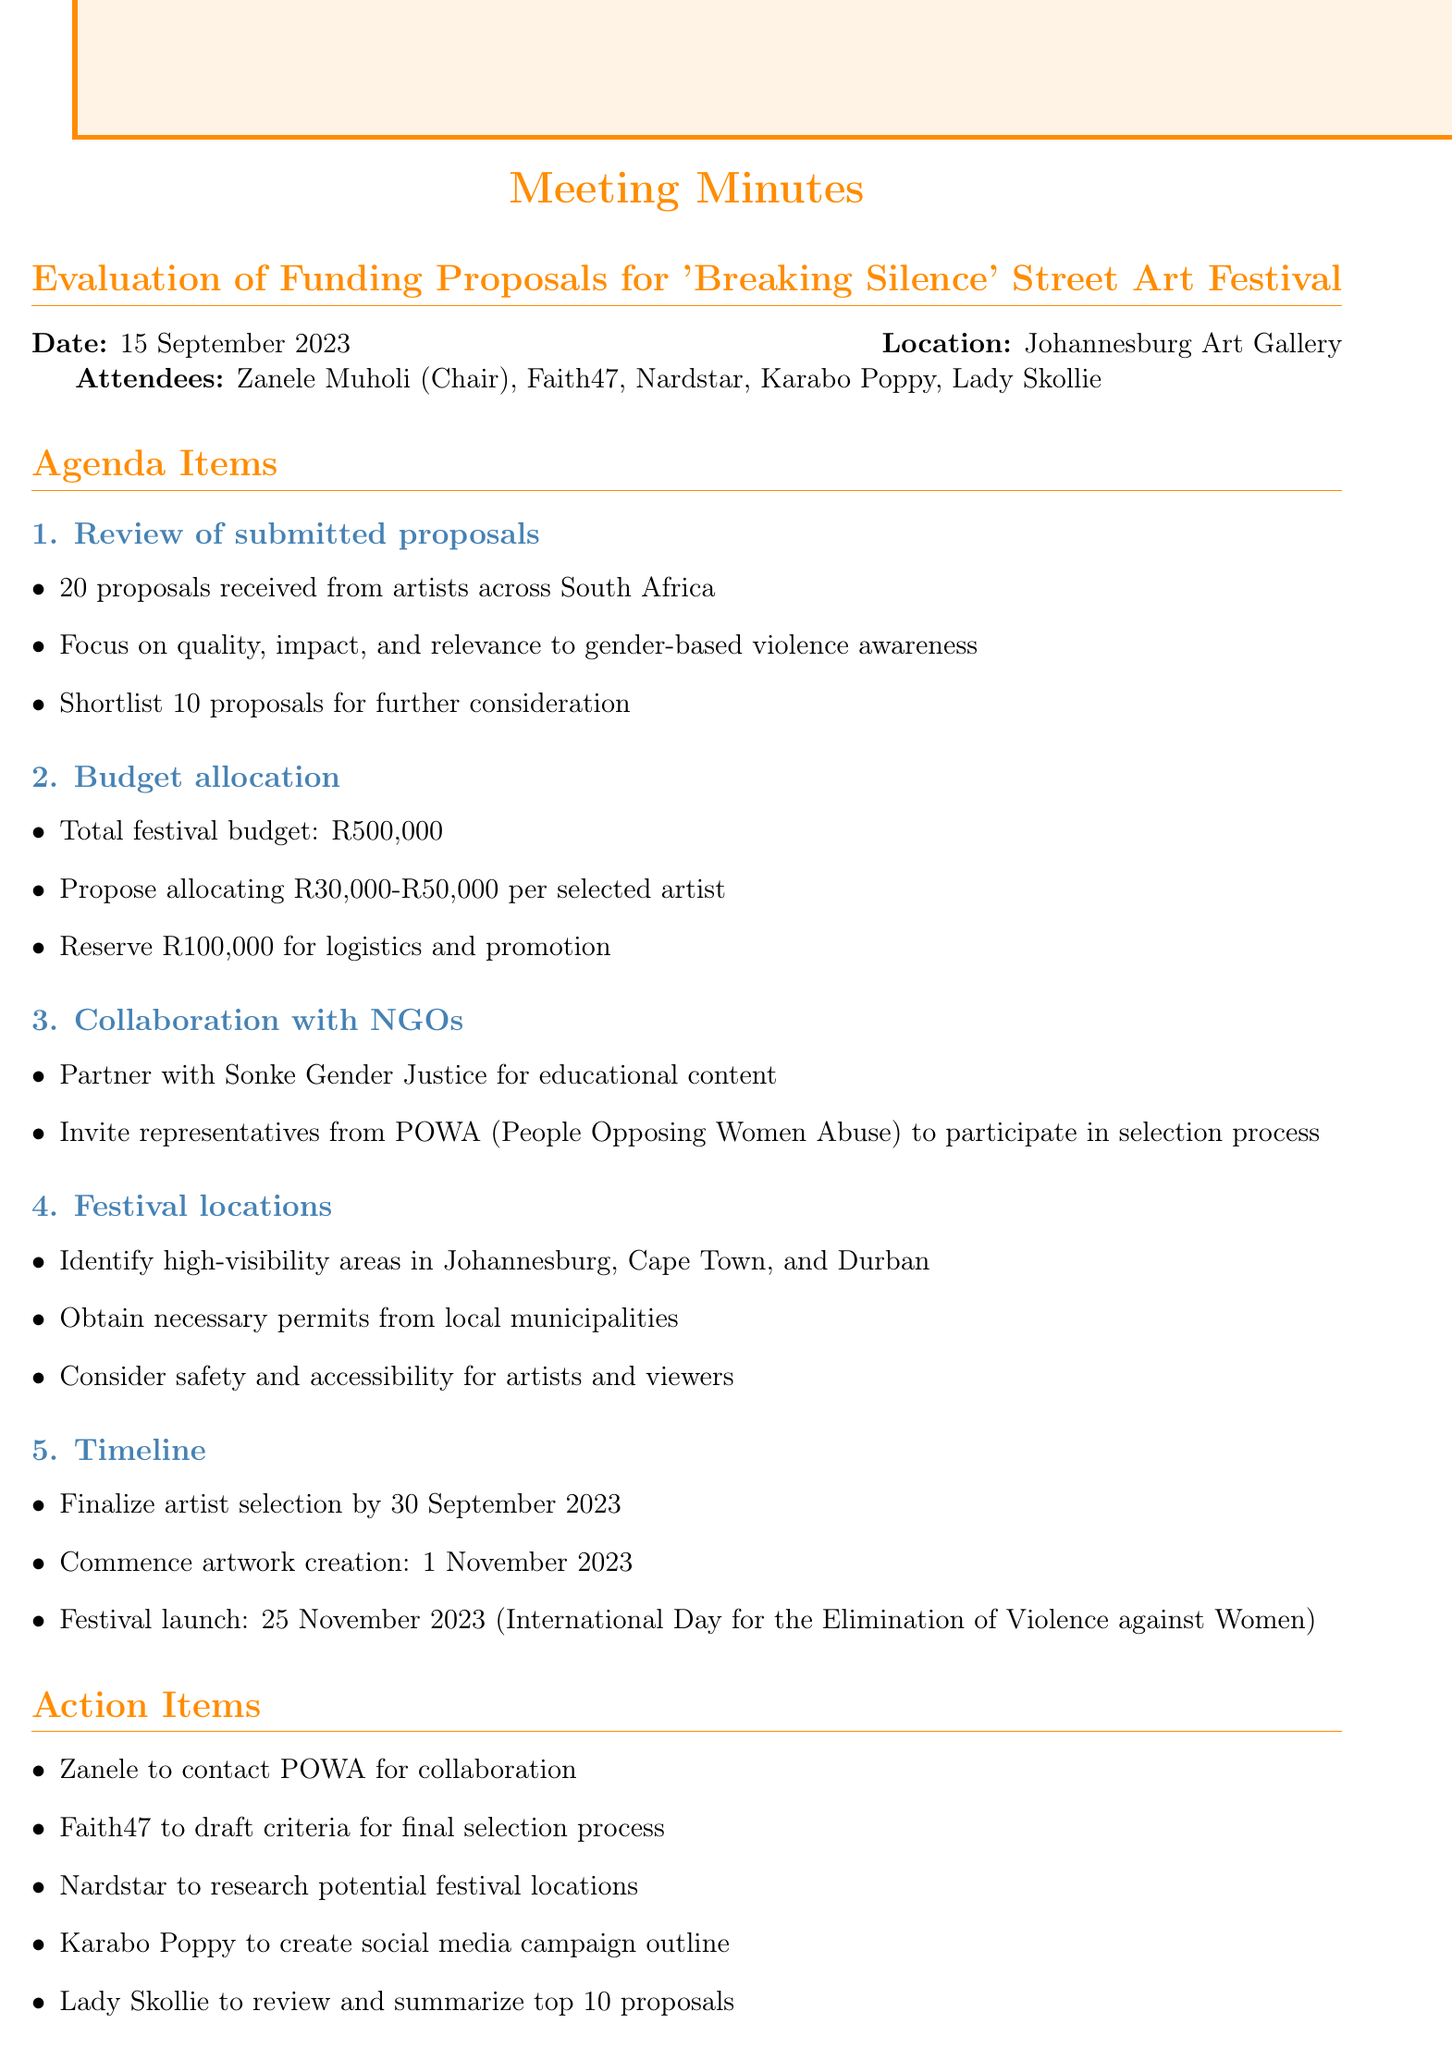what is the date of the meeting? The date of the meeting is specified in the document as "15 September 2023".
Answer: 15 September 2023 how many proposals were received? The document states that a total of "20 proposals" were received from artists.
Answer: 20 proposals what is the total festival budget? The total budget for the festival is indicated as "R500,000".
Answer: R500,000 who is leading the collaboration with NGOs? The notes mention "Zanele" as the person to contact POWA for collaboration.
Answer: Zanele what is the proposed budget range per artist? The document specifies a range for artist allocation as "R30,000-R50,000".
Answer: R30,000-R50,000 when does artwork creation commence? The timeline indicates that artwork creation will start on "1 November 2023".
Answer: 1 November 2023 what is one of the festival locations mentioned? The document lists "Johannesburg" as one of the cities for festival locations.
Answer: Johannesburg what is the purpose of the festival? The festival is focused on raising awareness about "gender-based violence".
Answer: gender-based violence how many proposals will be shortlisted for further consideration? According to the document, "10 proposals" will be shortlisted.
Answer: 10 proposals 